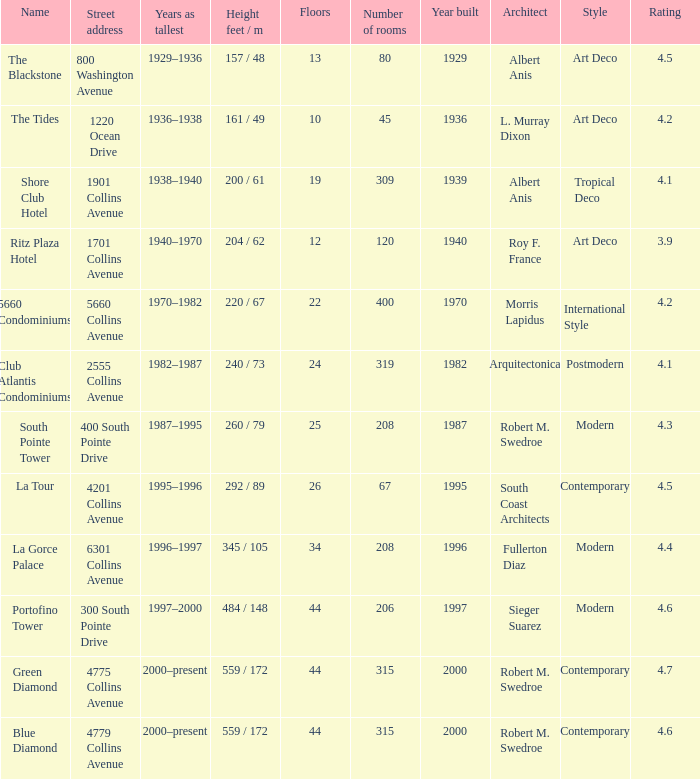How many years was the building with 24 floors the tallest? 1982–1987. 